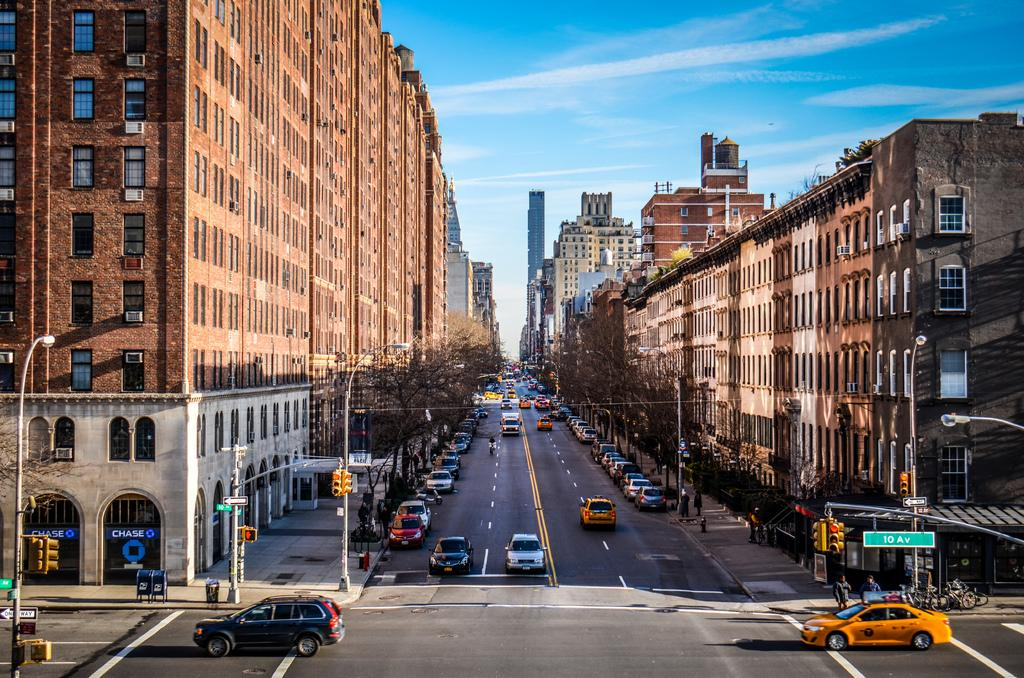Provide a one-sentence caption for the provided image. A road with tall buildings and a blue sky with a street sign that says 10 AV. 